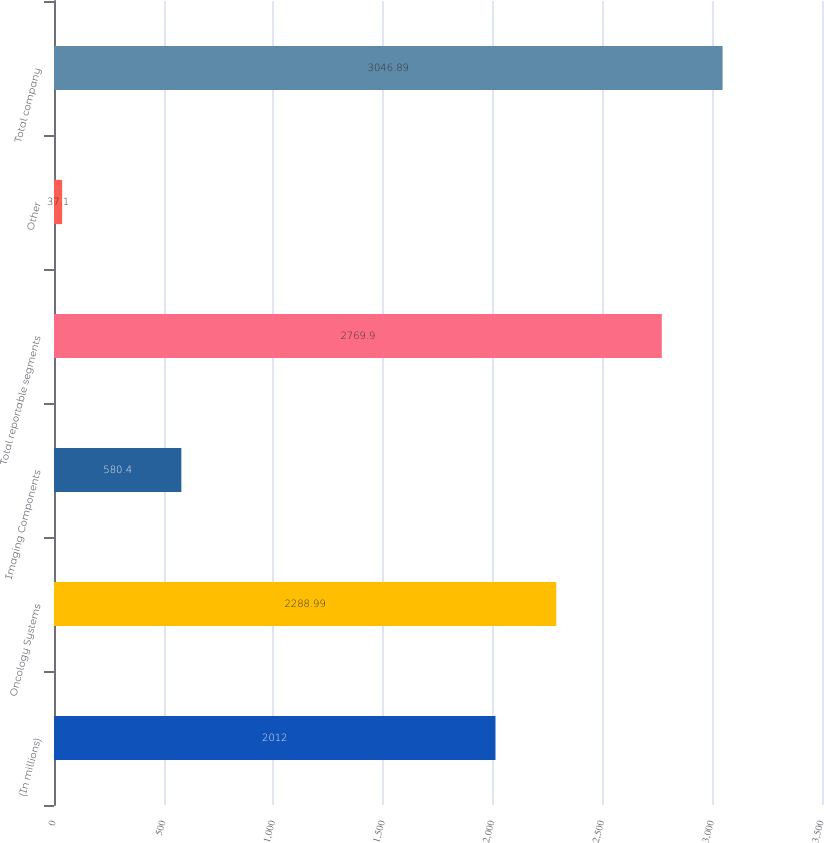Convert chart to OTSL. <chart><loc_0><loc_0><loc_500><loc_500><bar_chart><fcel>(In millions)<fcel>Oncology Systems<fcel>Imaging Components<fcel>Total reportable segments<fcel>Other<fcel>Total company<nl><fcel>2012<fcel>2288.99<fcel>580.4<fcel>2769.9<fcel>37.1<fcel>3046.89<nl></chart> 